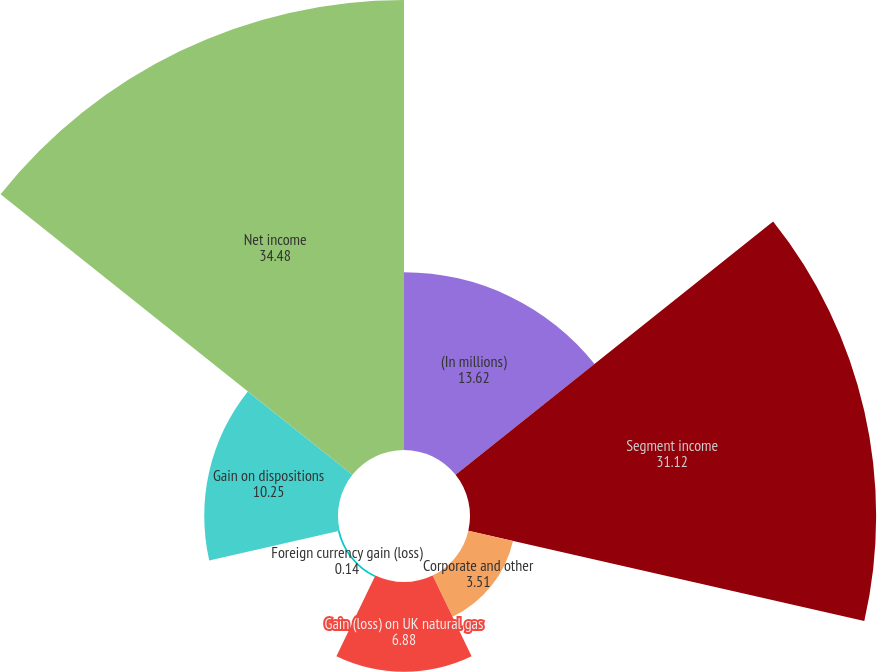<chart> <loc_0><loc_0><loc_500><loc_500><pie_chart><fcel>(In millions)<fcel>Segment income<fcel>Corporate and other<fcel>Gain (loss) on UK natural gas<fcel>Foreign currency gain (loss)<fcel>Gain on dispositions<fcel>Net income<nl><fcel>13.62%<fcel>31.12%<fcel>3.51%<fcel>6.88%<fcel>0.14%<fcel>10.25%<fcel>34.48%<nl></chart> 